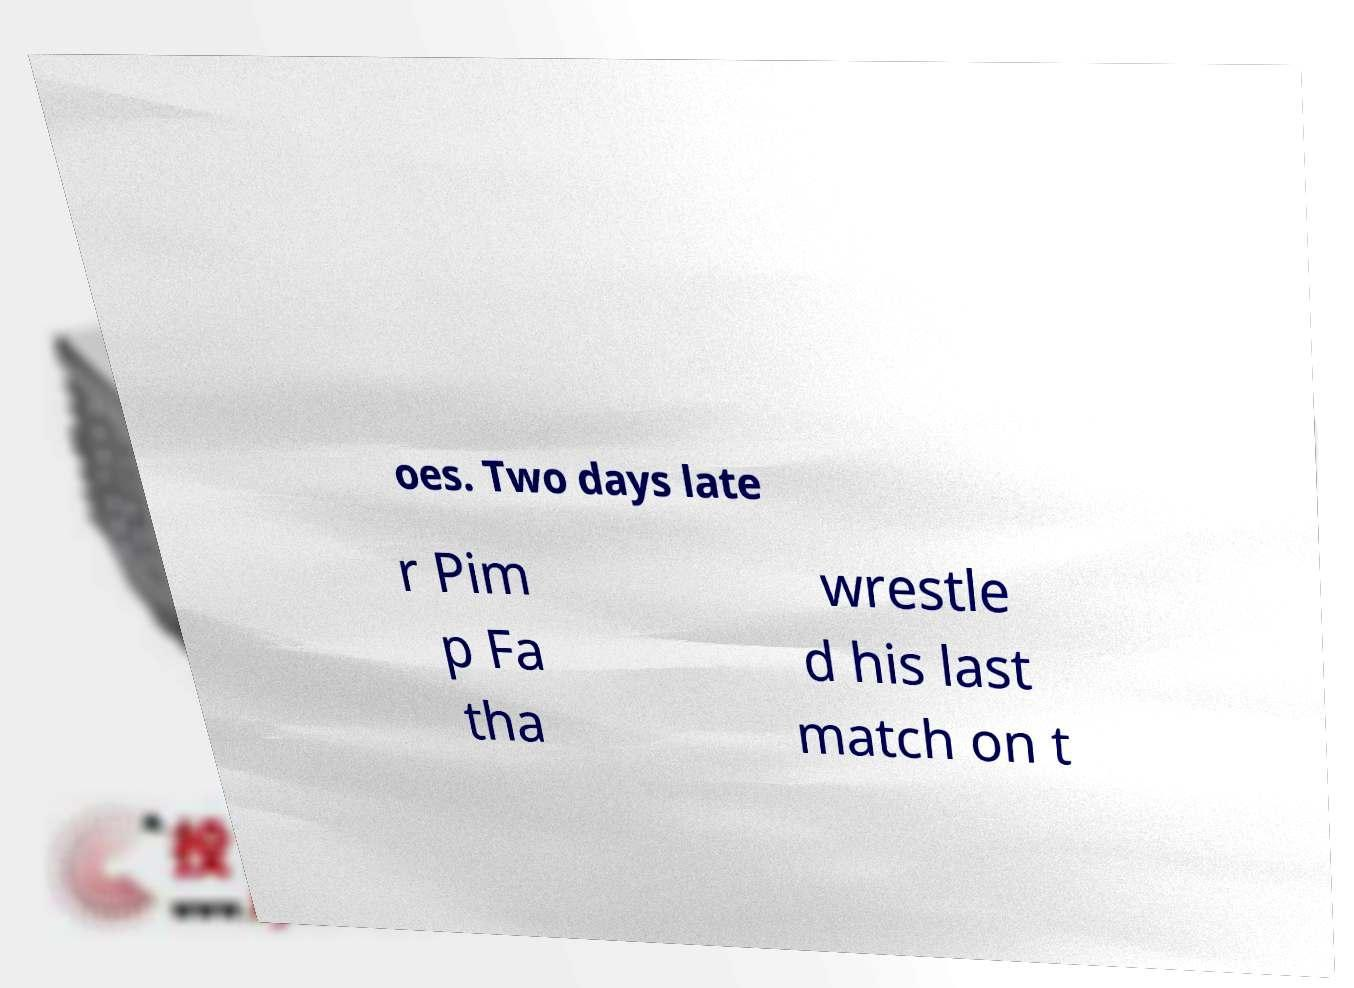Could you assist in decoding the text presented in this image and type it out clearly? oes. Two days late r Pim p Fa tha wrestle d his last match on t 